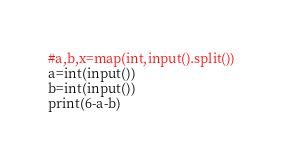Convert code to text. <code><loc_0><loc_0><loc_500><loc_500><_Python_>#a,b,x=map(int,input().split())
a=int(input())
b=int(input())
print(6-a-b)
</code> 